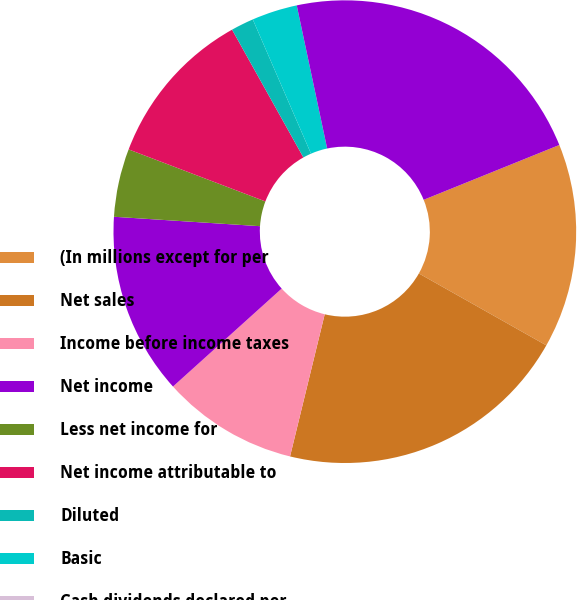Convert chart to OTSL. <chart><loc_0><loc_0><loc_500><loc_500><pie_chart><fcel>(In millions except for per<fcel>Net sales<fcel>Income before income taxes<fcel>Net income<fcel>Less net income for<fcel>Net income attributable to<fcel>Diluted<fcel>Basic<fcel>Cash dividends declared per<fcel>Total assets<nl><fcel>14.29%<fcel>20.63%<fcel>9.52%<fcel>12.7%<fcel>4.76%<fcel>11.11%<fcel>1.59%<fcel>3.18%<fcel>0.0%<fcel>22.22%<nl></chart> 